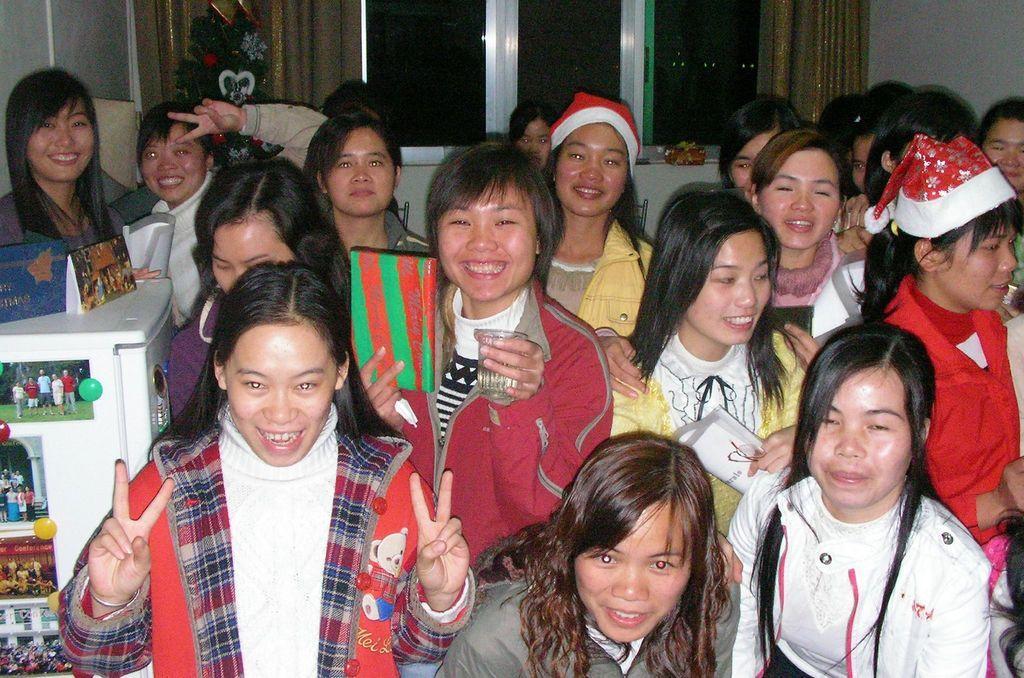Describe this image in one or two sentences. In this image in the foreground there are a group of people who are standing and smiling, and some of them are wearing some hats. On the left side there is one fridge, on the fridge there are some photos and in the background there is a window, curtains, plant, and a wall. 